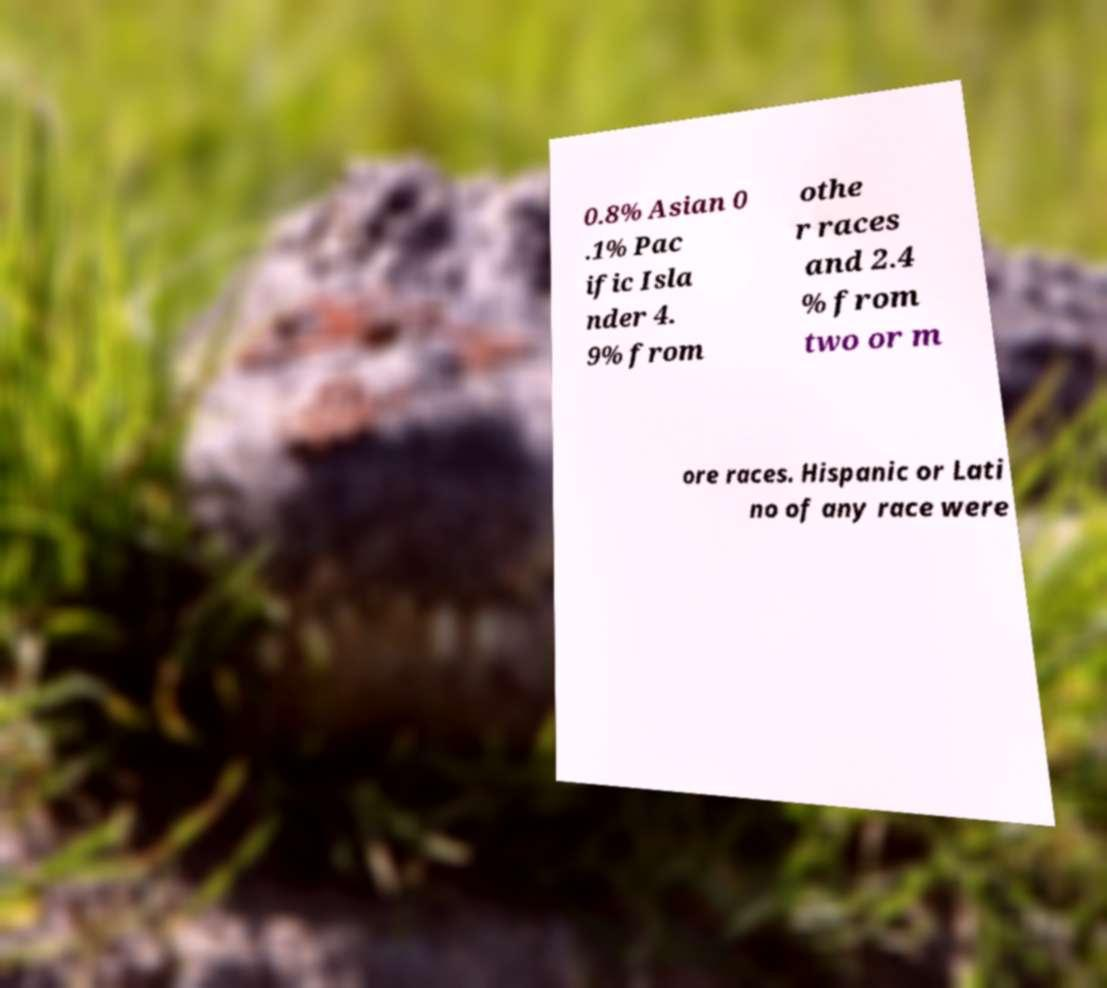There's text embedded in this image that I need extracted. Can you transcribe it verbatim? 0.8% Asian 0 .1% Pac ific Isla nder 4. 9% from othe r races and 2.4 % from two or m ore races. Hispanic or Lati no of any race were 